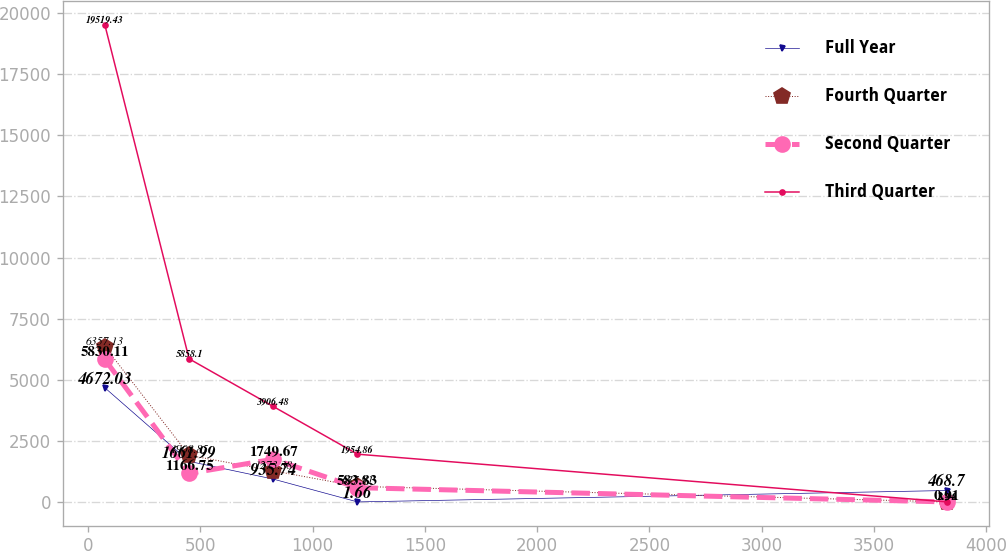Convert chart to OTSL. <chart><loc_0><loc_0><loc_500><loc_500><line_chart><ecel><fcel>Full Year<fcel>Fourth Quarter<fcel>Second Quarter<fcel>Third Quarter<nl><fcel>74.21<fcel>4672.03<fcel>6357.13<fcel>5830.11<fcel>19519.4<nl><fcel>449.38<fcel>1661.99<fcel>1908.85<fcel>1166.75<fcel>5858.1<nl><fcel>824.55<fcel>935.74<fcel>1273.38<fcel>1749.67<fcel>3906.48<nl><fcel>1199.72<fcel>1.66<fcel>637.91<fcel>583.83<fcel>1954.86<nl><fcel>3825.9<fcel>468.7<fcel>2.44<fcel>0.91<fcel>3.24<nl></chart> 